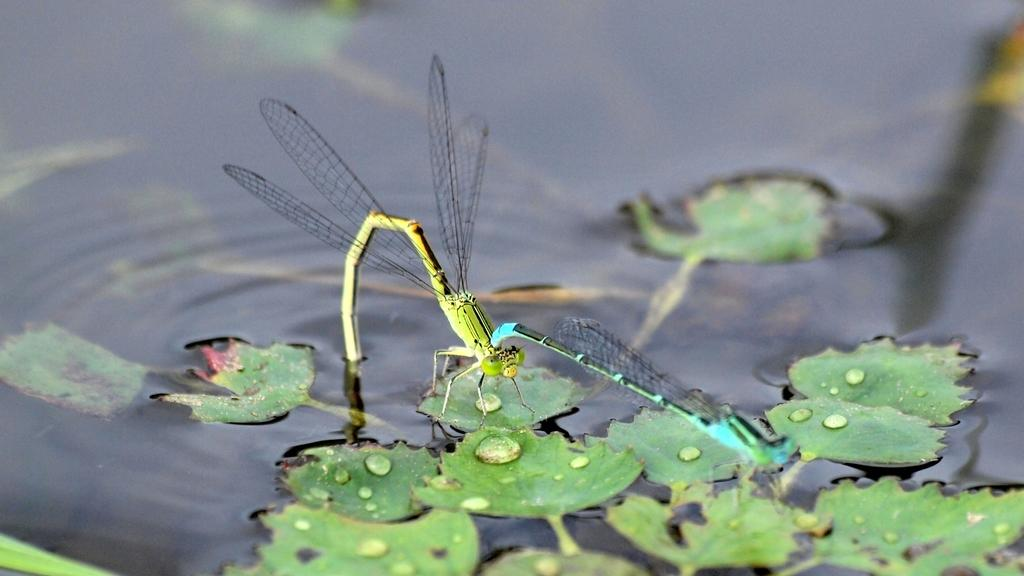What type of insects can be seen in the image? There are dragonflies in the image. What type of plant parts are visible in the image? There are leaves and stems in the image. What natural feature is present in the image? The image contains a water body. What type of comfort does the mom provide to the cows in the image? There are no cows or moms present in the image; it features dragonflies, leaves, stems, and a water body. 